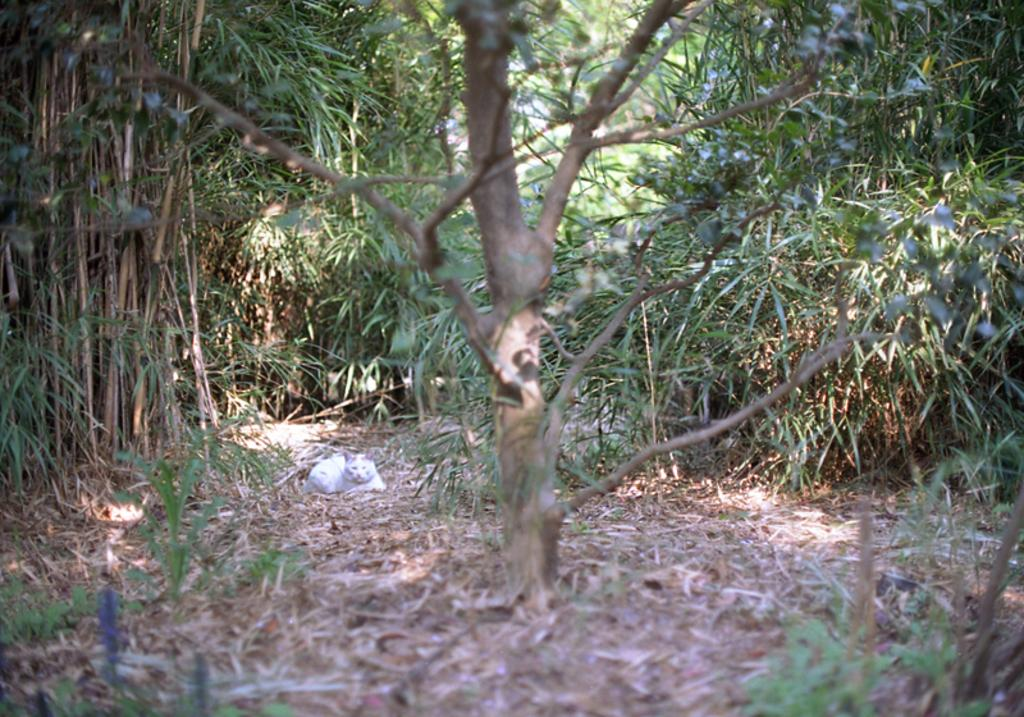What type of natural environment is depicted in the image? The image contains a forest. What can be found on the surface of the forest floor? There are dried leaves on the surface of the forest floor. What type of trees are present in the forest? Bamboo trees are present in the forest. Are there any other types of plants in the forest besides bamboo trees? Yes, there are plants in the forest. Can you describe the river flowing through the forest in the image? There is no river present in the image; it depicts a forest with dried leaves, bamboo trees, and other plants. How many cows are grazing in the forest in the image? There are no cows present in the image; it depicts a forest with dried leaves, bamboo trees, and other plants. 